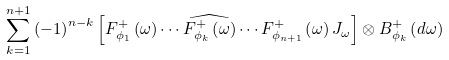Convert formula to latex. <formula><loc_0><loc_0><loc_500><loc_500>\sum _ { k = 1 } ^ { n + 1 } \left ( - 1 \right ) ^ { n - k } \left [ F _ { \phi _ { 1 } } ^ { + } \left ( \omega \right ) \cdots \widehat { F _ { \phi _ { k } } ^ { + } \left ( \omega \right ) } \cdots F _ { \phi _ { n + 1 } } ^ { + } \left ( \omega \right ) J _ { \omega } \right ] \otimes B _ { \phi _ { k } } ^ { + } \left ( d \omega \right )</formula> 